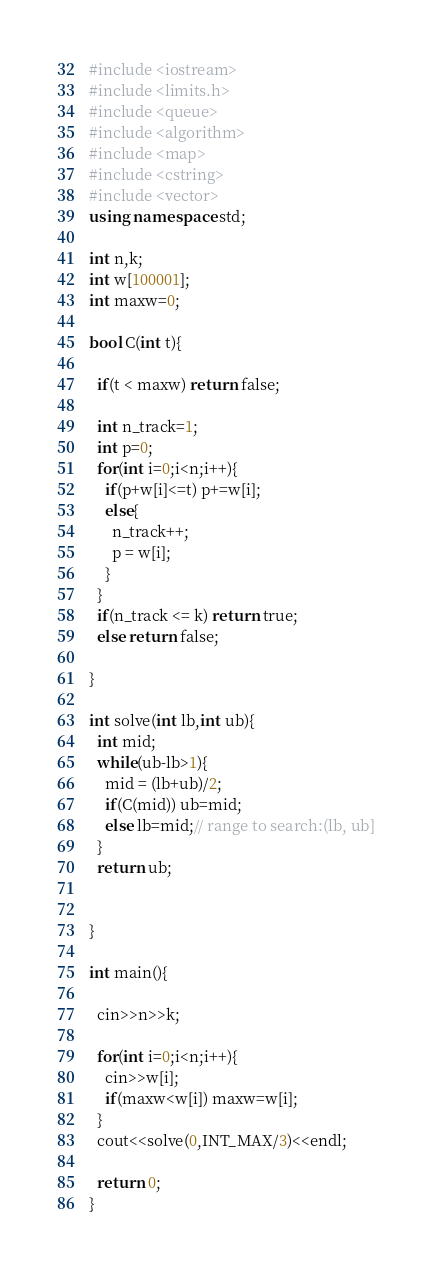<code> <loc_0><loc_0><loc_500><loc_500><_C++_>#include <iostream>
#include <limits.h>
#include <queue>
#include <algorithm>
#include <map>
#include <cstring>
#include <vector>
using namespace std;

int n,k;
int w[100001];
int maxw=0;

bool C(int t){

  if(t < maxw) return false;
  
  int n_track=1;
  int p=0;
  for(int i=0;i<n;i++){
    if(p+w[i]<=t) p+=w[i];
    else{
      n_track++;
      p = w[i];
    }
  }
  if(n_track <= k) return true;
  else return false;
  
}

int solve(int lb,int ub){
  int mid;
  while(ub-lb>1){
    mid = (lb+ub)/2;
    if(C(mid)) ub=mid;
    else lb=mid;// range to search:(lb, ub]
  }
  return ub;


}
 
int main(){

  cin>>n>>k;
  
  for(int i=0;i<n;i++){
    cin>>w[i];
    if(maxw<w[i]) maxw=w[i];
  }
  cout<<solve(0,INT_MAX/3)<<endl; 
  
  return 0;
}</code> 